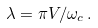Convert formula to latex. <formula><loc_0><loc_0><loc_500><loc_500>\lambda = \pi V / \omega _ { c } \, .</formula> 